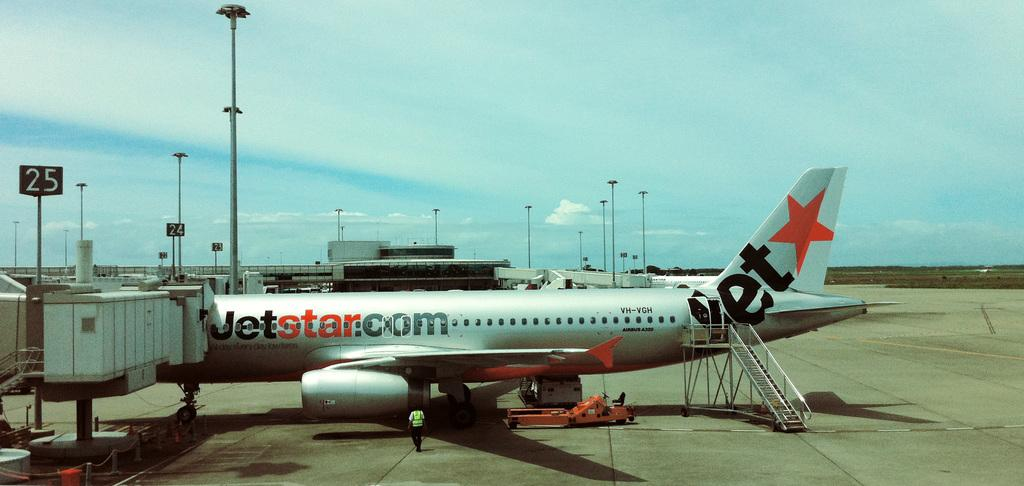What is the main subject of the image? The main subject of the image is an aircraft. Where is the aircraft located in relation to the terminal? The aircraft is near a terminal. What is the person in the image doing? There is a person walking towards the aircraft. What type of building is visible in the image? There is an airport terminal visible in the image. What type of lighting is present in the image? There are lamp posts in the image. What type of hospital is visible in the image? There is no hospital present in the image; it features an aircraft near a terminal. How does the beginner learn to print in the image? There is no reference to learning or printing in the image. 